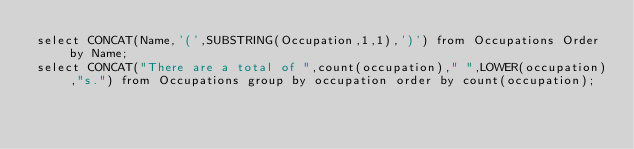<code> <loc_0><loc_0><loc_500><loc_500><_SQL_>select CONCAT(Name,'(',SUBSTRING(Occupation,1,1),')') from Occupations Order by Name;
select CONCAT("There are a total of ",count(occupation)," ",LOWER(occupation),"s.") from Occupations group by occupation order by count(occupation);</code> 